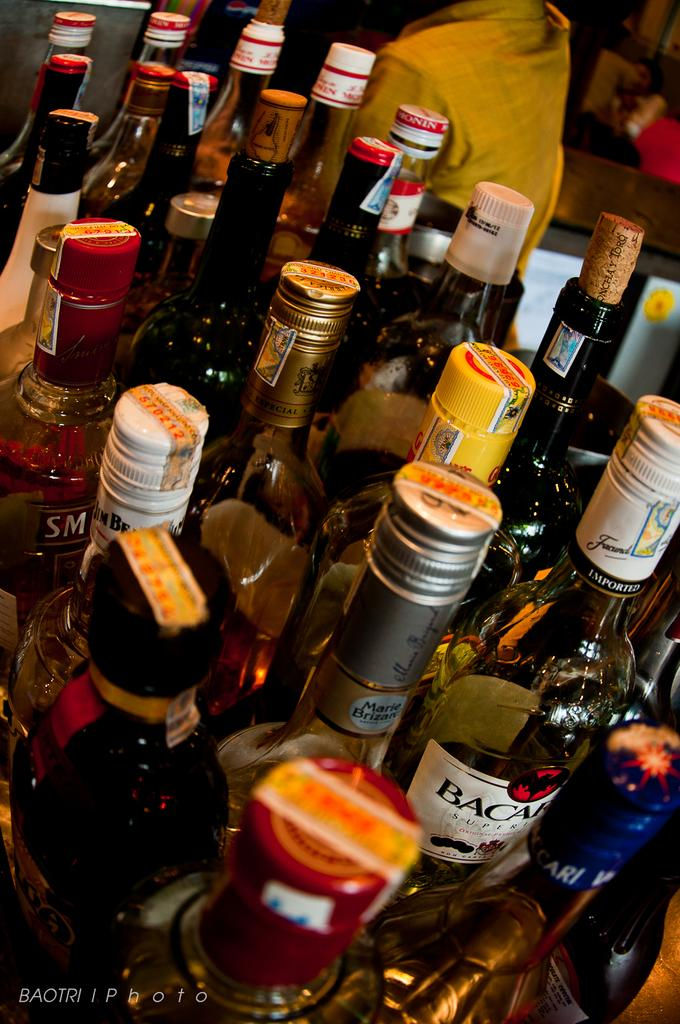What type of bottles are visible in the image? There are wine bottles in the image. Can you describe the person in the background of the image? Unfortunately, the provided facts do not give any details about the person in the background. What type of clouds can be seen in the image? There is no mention of clouds in the provided facts, so we cannot determine if any are present in the image. 